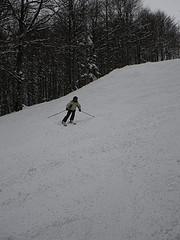At most what temperature does it generally have to be to produce these conditions?
Quick response, please. 32. What direction is the person skiing in?
Concise answer only. Downhill. Is this person skiing with friends?
Quick response, please. No. 